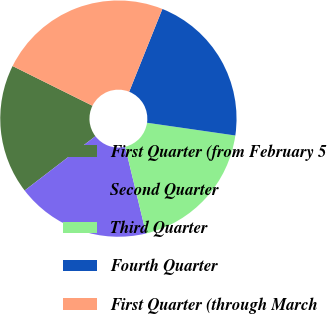Convert chart to OTSL. <chart><loc_0><loc_0><loc_500><loc_500><pie_chart><fcel>First Quarter (from February 5<fcel>Second Quarter<fcel>Third Quarter<fcel>Fourth Quarter<fcel>First Quarter (through March<nl><fcel>17.75%<fcel>18.35%<fcel>18.95%<fcel>21.21%<fcel>23.73%<nl></chart> 